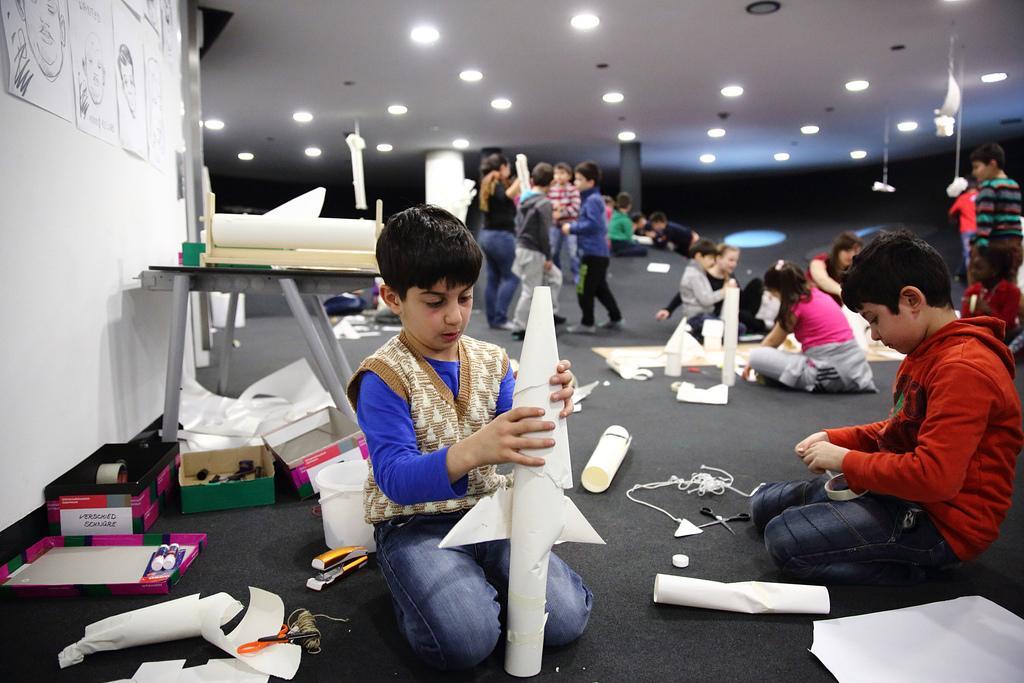Could you give a brief overview of what you see in this image? In the foreground of this image, there is a boy making a paper craft and we can also see craft items around him. On the right, there is another boy holding a tape. Behind them, there are few objects on the table, few cardboard boxes and papers pasted on a wall. In the background, there are few people standing and sitting on the floor, lights to the ceiling and few crafts objects on the floor 